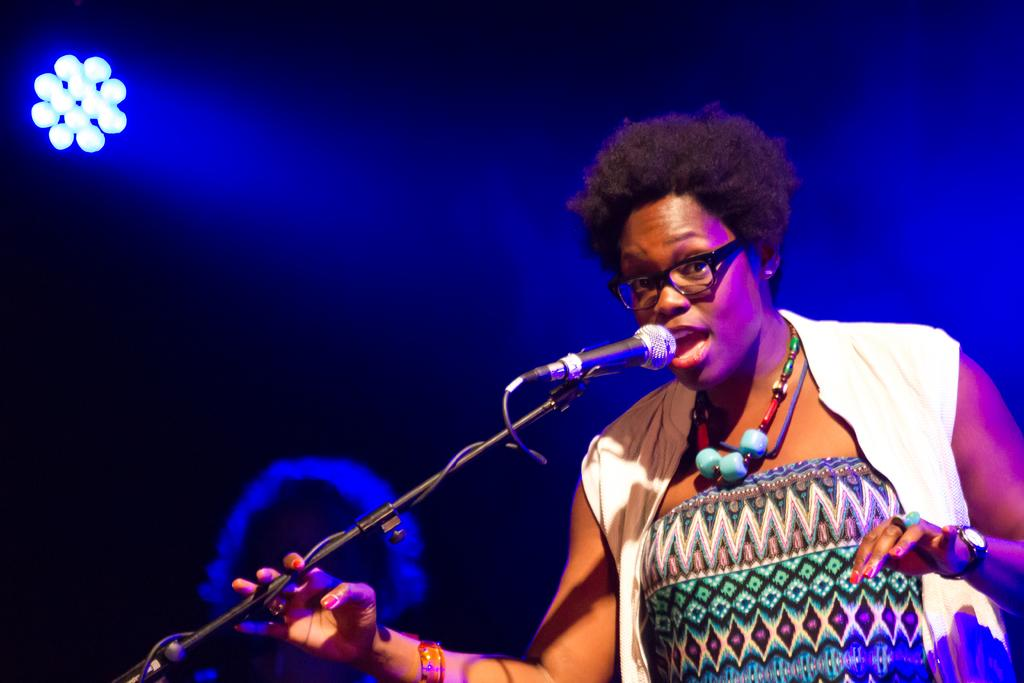What is the main subject of the image? There is a person standing in the image. What can be seen near the person? There is a mic placed on a stand. What is visible in the background of the image? There are lights visible in the background. Are there any other people present in the image? Yes, there is another person in the background. What type of road can be seen in the image? There is no road present in the image. Can you describe the fly that is buzzing around the person in the image? There is no fly present in the image. 